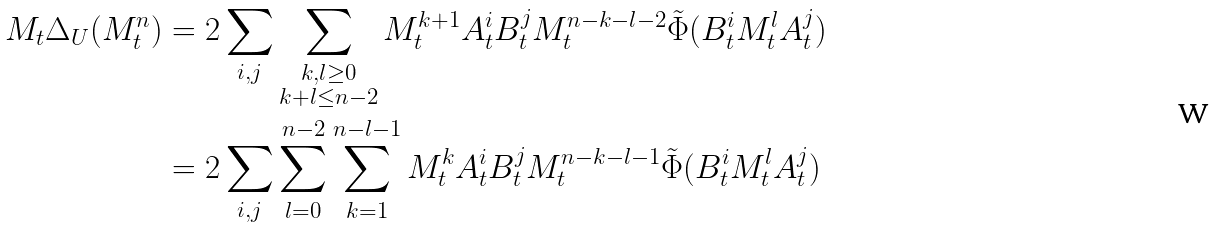Convert formula to latex. <formula><loc_0><loc_0><loc_500><loc_500>M _ { t } \Delta _ { U } ( M _ { t } ^ { n } ) & = 2 \sum _ { i , j } \sum _ { \substack { k , l \geq 0 \\ k + l \leq n - 2 } } M _ { t } ^ { k + 1 } A _ { t } ^ { i } B _ { t } ^ { j } M _ { t } ^ { n - k - l - 2 } \tilde { \Phi } ( B _ { t } ^ { i } M _ { t } ^ { l } A _ { t } ^ { j } ) \\ & = 2 \sum _ { i , j } \sum _ { l = 0 } ^ { n - 2 } \sum _ { k = 1 } ^ { n - l - 1 } M _ { t } ^ { k } A _ { t } ^ { i } B _ { t } ^ { j } M _ { t } ^ { n - k - l - 1 } \tilde { \Phi } ( B _ { t } ^ { i } M _ { t } ^ { l } A _ { t } ^ { j } )</formula> 